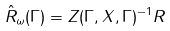<formula> <loc_0><loc_0><loc_500><loc_500>\hat { R } _ { \omega } ( \Gamma ) = Z ( \Gamma , X , \Gamma ) ^ { - 1 } R</formula> 